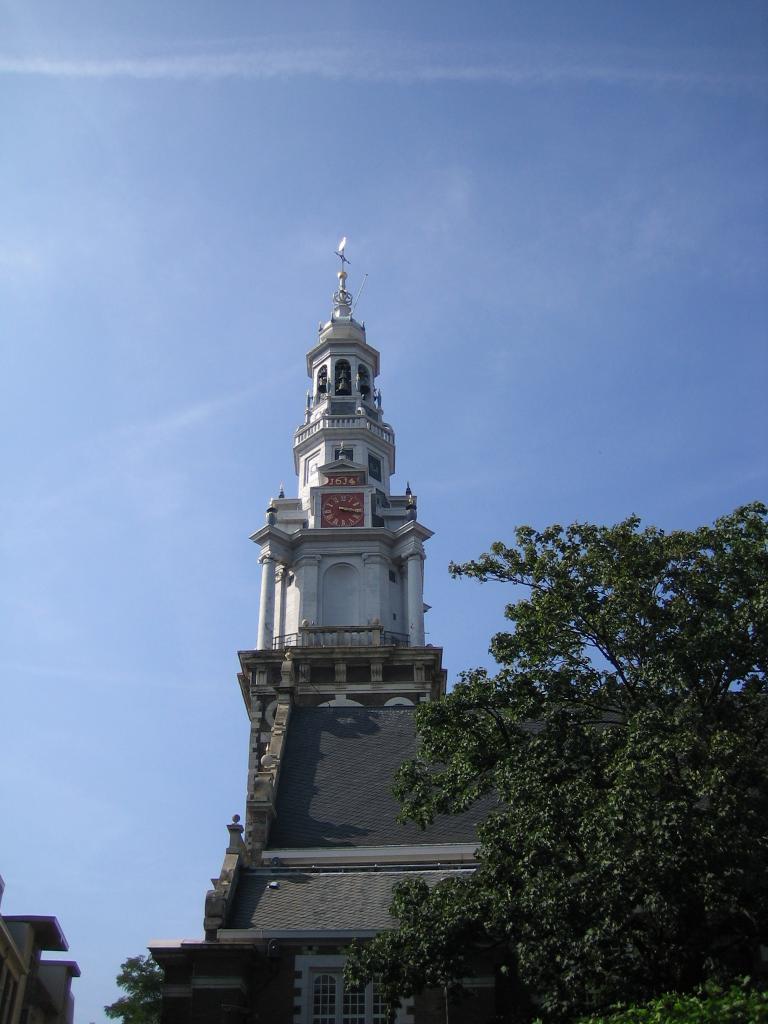Can you describe this image briefly? There is a tower on a building in the middle of this image. We can see a tree on the right side of this image and the blue sky is in the background. 